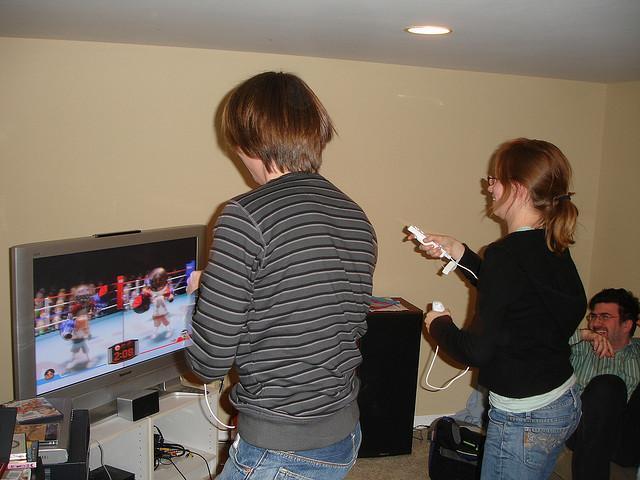How many people in this photo?
Give a very brief answer. 3. How many people can be seen?
Give a very brief answer. 3. How many clocks can be seen?
Give a very brief answer. 0. 